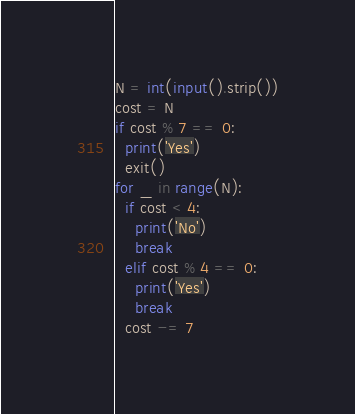Convert code to text. <code><loc_0><loc_0><loc_500><loc_500><_Python_>N = int(input().strip())
cost = N
if cost % 7 == 0:
  print('Yes')
  exit()
for _ in range(N):
  if cost < 4:
    print('No')
    break
  elif cost % 4 == 0:
    print('Yes')
    break
  cost -= 7</code> 